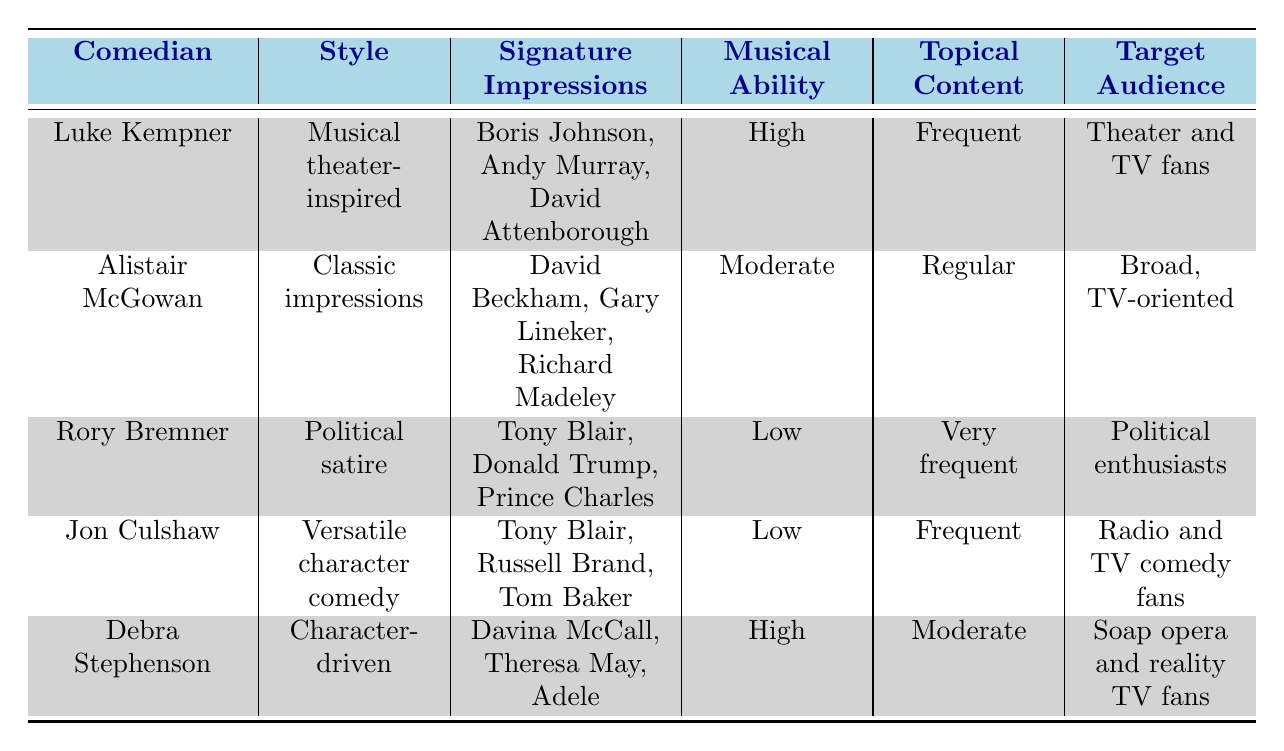What style does Luke Kempner use in his comedy? The table indicates that Luke Kempner's comedy style is "Musical theater-inspired."
Answer: Musical theater-inspired Which comedian has the highest musical ability? Luke Kempner and Debra Stephenson both have high musical ability, while Rory Bremner and Jon Culshaw have low musical ability. Thus, Luke Kempner and Debra Stephenson share the highest rating.
Answer: Luke Kempner and Debra Stephenson Is Rory Bremner known for character-driven comedy? The table shows that Rory Bremner's style is "Political satire," not character-driven.
Answer: No What is the target audience for Alistair McGowan? According to the table, Alistair McGowan's target audience is described as "Broad, TV-oriented."
Answer: Broad, TV-oriented How many comedians use musical ability as a high level? From the table, Luke Kempner and Debra Stephenson are the only two comedians with a high level of musical ability. Therefore, there are two comedians.
Answer: 2 Which comedian uses minimal props in their performances? Luke Kempner's use of props is noted as "Minimal" in the table, indicating he relies on fewer props compared to others.
Answer: Luke Kempner Who has a very frequent use of topical content? The table lists Rory Bremner as having "Very frequent" topical content usage, so he is the comedian noted for this characteristic.
Answer: Rory Bremner What is the signature impression of Jon Culshaw? Jon Culshaw's signature impressions listed in the table are Tony Blair, Russell Brand, and Tom Baker.
Answer: Tony Blair, Russell Brand, Tom Baker Which comedian is active on social media but not as much as Luke Kempner? Alistair McGowan and Debra Stephenson have moderate social media presence, while Rory Bremner and Jon Culshaw are active but don't match Kempner's "Very active" presence. Hence, Alistair McGowan is less active than Luke Kempner.
Answer: Alistair McGowan 